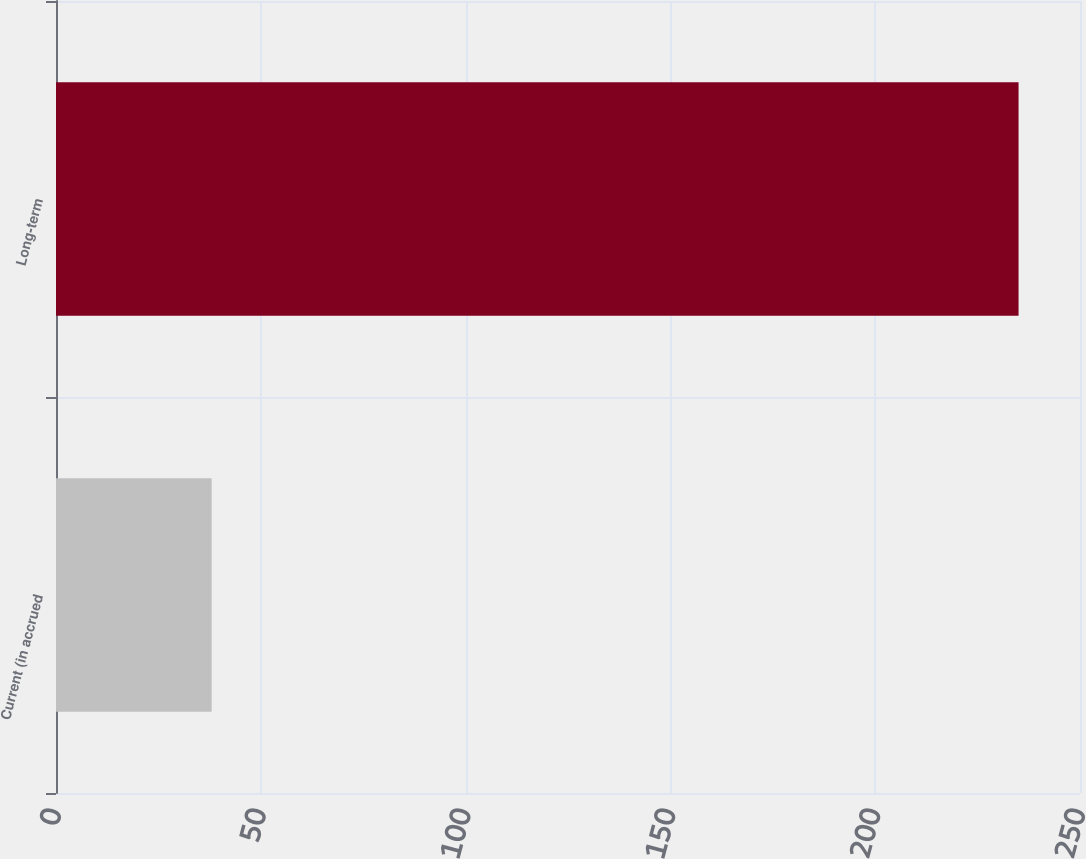<chart> <loc_0><loc_0><loc_500><loc_500><bar_chart><fcel>Current (in accrued<fcel>Long-term<nl><fcel>38<fcel>235<nl></chart> 